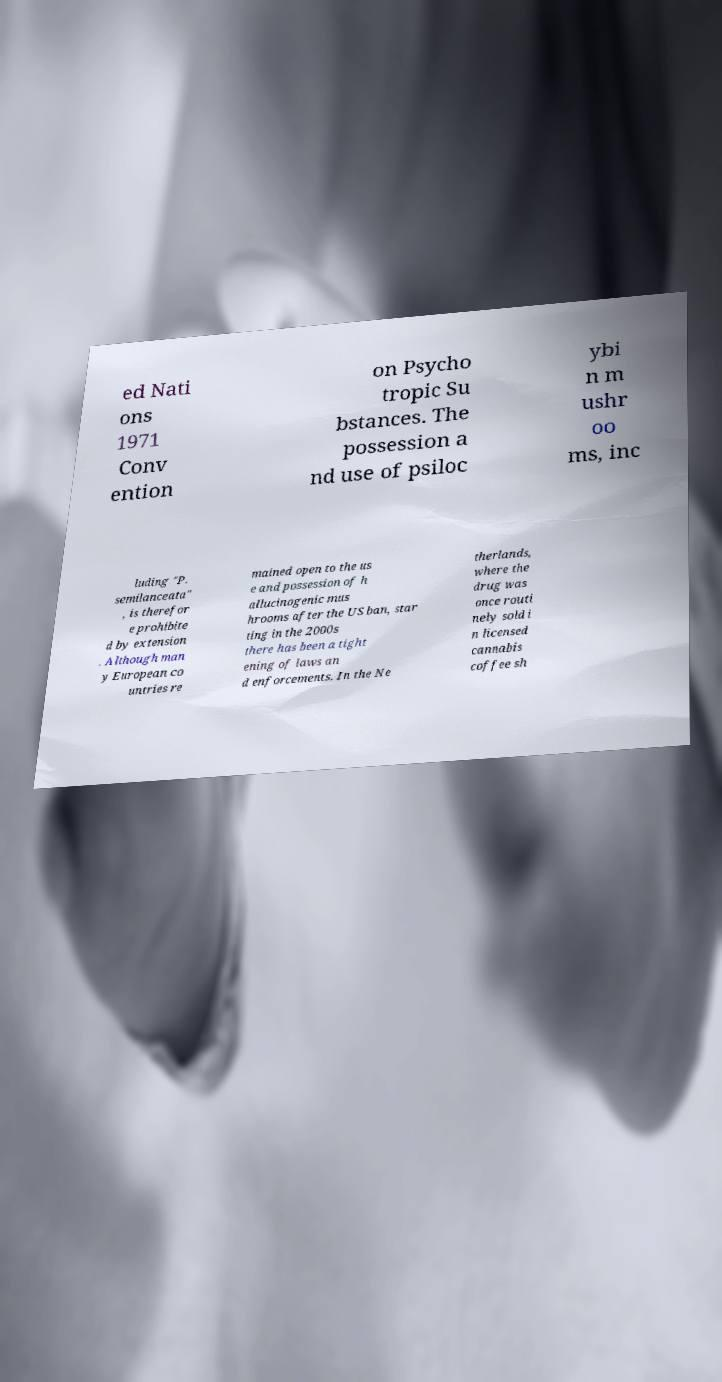Could you assist in decoding the text presented in this image and type it out clearly? ed Nati ons 1971 Conv ention on Psycho tropic Su bstances. The possession a nd use of psiloc ybi n m ushr oo ms, inc luding "P. semilanceata" , is therefor e prohibite d by extension . Although man y European co untries re mained open to the us e and possession of h allucinogenic mus hrooms after the US ban, star ting in the 2000s there has been a tight ening of laws an d enforcements. In the Ne therlands, where the drug was once routi nely sold i n licensed cannabis coffee sh 